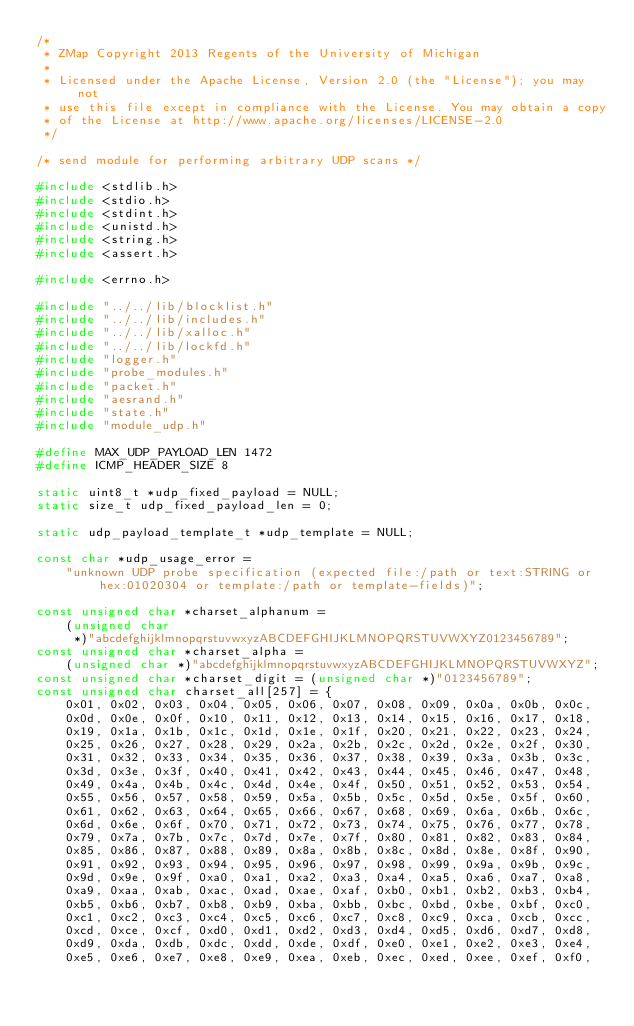<code> <loc_0><loc_0><loc_500><loc_500><_C_>/*
 * ZMap Copyright 2013 Regents of the University of Michigan
 *
 * Licensed under the Apache License, Version 2.0 (the "License"); you may not
 * use this file except in compliance with the License. You may obtain a copy
 * of the License at http://www.apache.org/licenses/LICENSE-2.0
 */

/* send module for performing arbitrary UDP scans */

#include <stdlib.h>
#include <stdio.h>
#include <stdint.h>
#include <unistd.h>
#include <string.h>
#include <assert.h>

#include <errno.h>

#include "../../lib/blocklist.h"
#include "../../lib/includes.h"
#include "../../lib/xalloc.h"
#include "../../lib/lockfd.h"
#include "logger.h"
#include "probe_modules.h"
#include "packet.h"
#include "aesrand.h"
#include "state.h"
#include "module_udp.h"

#define MAX_UDP_PAYLOAD_LEN 1472
#define ICMP_HEADER_SIZE 8

static uint8_t *udp_fixed_payload = NULL;
static size_t udp_fixed_payload_len = 0;

static udp_payload_template_t *udp_template = NULL;

const char *udp_usage_error =
    "unknown UDP probe specification (expected file:/path or text:STRING or hex:01020304 or template:/path or template-fields)";

const unsigned char *charset_alphanum =
    (unsigned char
	 *)"abcdefghijklmnopqrstuvwxyzABCDEFGHIJKLMNOPQRSTUVWXYZ0123456789";
const unsigned char *charset_alpha =
    (unsigned char *)"abcdefghijklmnopqrstuvwxyzABCDEFGHIJKLMNOPQRSTUVWXYZ";
const unsigned char *charset_digit = (unsigned char *)"0123456789";
const unsigned char charset_all[257] = {
    0x01, 0x02, 0x03, 0x04, 0x05, 0x06, 0x07, 0x08, 0x09, 0x0a, 0x0b, 0x0c,
    0x0d, 0x0e, 0x0f, 0x10, 0x11, 0x12, 0x13, 0x14, 0x15, 0x16, 0x17, 0x18,
    0x19, 0x1a, 0x1b, 0x1c, 0x1d, 0x1e, 0x1f, 0x20, 0x21, 0x22, 0x23, 0x24,
    0x25, 0x26, 0x27, 0x28, 0x29, 0x2a, 0x2b, 0x2c, 0x2d, 0x2e, 0x2f, 0x30,
    0x31, 0x32, 0x33, 0x34, 0x35, 0x36, 0x37, 0x38, 0x39, 0x3a, 0x3b, 0x3c,
    0x3d, 0x3e, 0x3f, 0x40, 0x41, 0x42, 0x43, 0x44, 0x45, 0x46, 0x47, 0x48,
    0x49, 0x4a, 0x4b, 0x4c, 0x4d, 0x4e, 0x4f, 0x50, 0x51, 0x52, 0x53, 0x54,
    0x55, 0x56, 0x57, 0x58, 0x59, 0x5a, 0x5b, 0x5c, 0x5d, 0x5e, 0x5f, 0x60,
    0x61, 0x62, 0x63, 0x64, 0x65, 0x66, 0x67, 0x68, 0x69, 0x6a, 0x6b, 0x6c,
    0x6d, 0x6e, 0x6f, 0x70, 0x71, 0x72, 0x73, 0x74, 0x75, 0x76, 0x77, 0x78,
    0x79, 0x7a, 0x7b, 0x7c, 0x7d, 0x7e, 0x7f, 0x80, 0x81, 0x82, 0x83, 0x84,
    0x85, 0x86, 0x87, 0x88, 0x89, 0x8a, 0x8b, 0x8c, 0x8d, 0x8e, 0x8f, 0x90,
    0x91, 0x92, 0x93, 0x94, 0x95, 0x96, 0x97, 0x98, 0x99, 0x9a, 0x9b, 0x9c,
    0x9d, 0x9e, 0x9f, 0xa0, 0xa1, 0xa2, 0xa3, 0xa4, 0xa5, 0xa6, 0xa7, 0xa8,
    0xa9, 0xaa, 0xab, 0xac, 0xad, 0xae, 0xaf, 0xb0, 0xb1, 0xb2, 0xb3, 0xb4,
    0xb5, 0xb6, 0xb7, 0xb8, 0xb9, 0xba, 0xbb, 0xbc, 0xbd, 0xbe, 0xbf, 0xc0,
    0xc1, 0xc2, 0xc3, 0xc4, 0xc5, 0xc6, 0xc7, 0xc8, 0xc9, 0xca, 0xcb, 0xcc,
    0xcd, 0xce, 0xcf, 0xd0, 0xd1, 0xd2, 0xd3, 0xd4, 0xd5, 0xd6, 0xd7, 0xd8,
    0xd9, 0xda, 0xdb, 0xdc, 0xdd, 0xde, 0xdf, 0xe0, 0xe1, 0xe2, 0xe3, 0xe4,
    0xe5, 0xe6, 0xe7, 0xe8, 0xe9, 0xea, 0xeb, 0xec, 0xed, 0xee, 0xef, 0xf0,</code> 